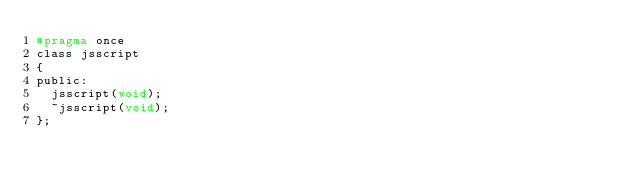Convert code to text. <code><loc_0><loc_0><loc_500><loc_500><_C_>#pragma once
class jsscript
{
public:
	jsscript(void);
	~jsscript(void);
};

</code> 